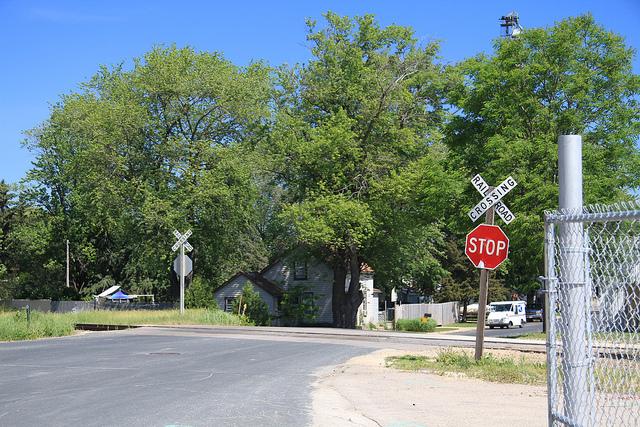How many trains are on the track?
Concise answer only. 0. Where is the railroad crossing?
Quick response, please. Ahead. How many stop signs is there?
Quick response, please. 2. Is there a train track near the metal fence?
Give a very brief answer. Yes. Is there a bike path in this photo?
Give a very brief answer. No. 